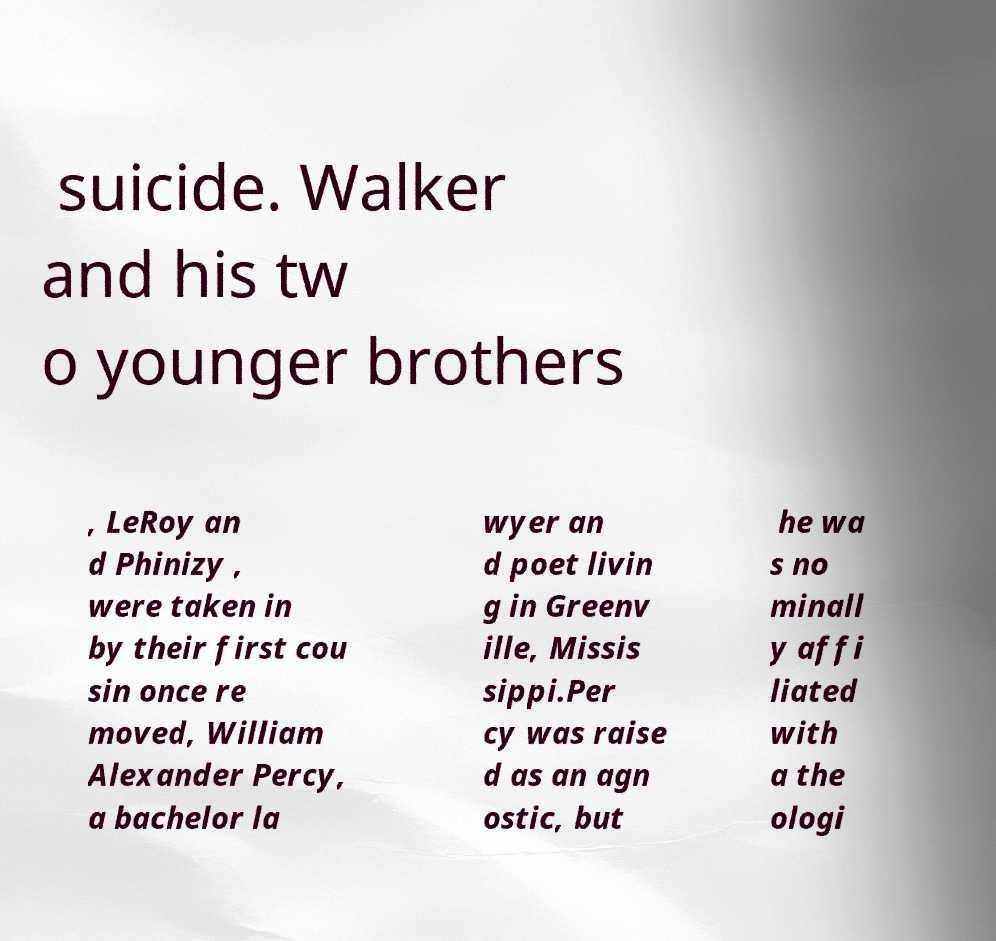What messages or text are displayed in this image? I need them in a readable, typed format. suicide. Walker and his tw o younger brothers , LeRoy an d Phinizy , were taken in by their first cou sin once re moved, William Alexander Percy, a bachelor la wyer an d poet livin g in Greenv ille, Missis sippi.Per cy was raise d as an agn ostic, but he wa s no minall y affi liated with a the ologi 